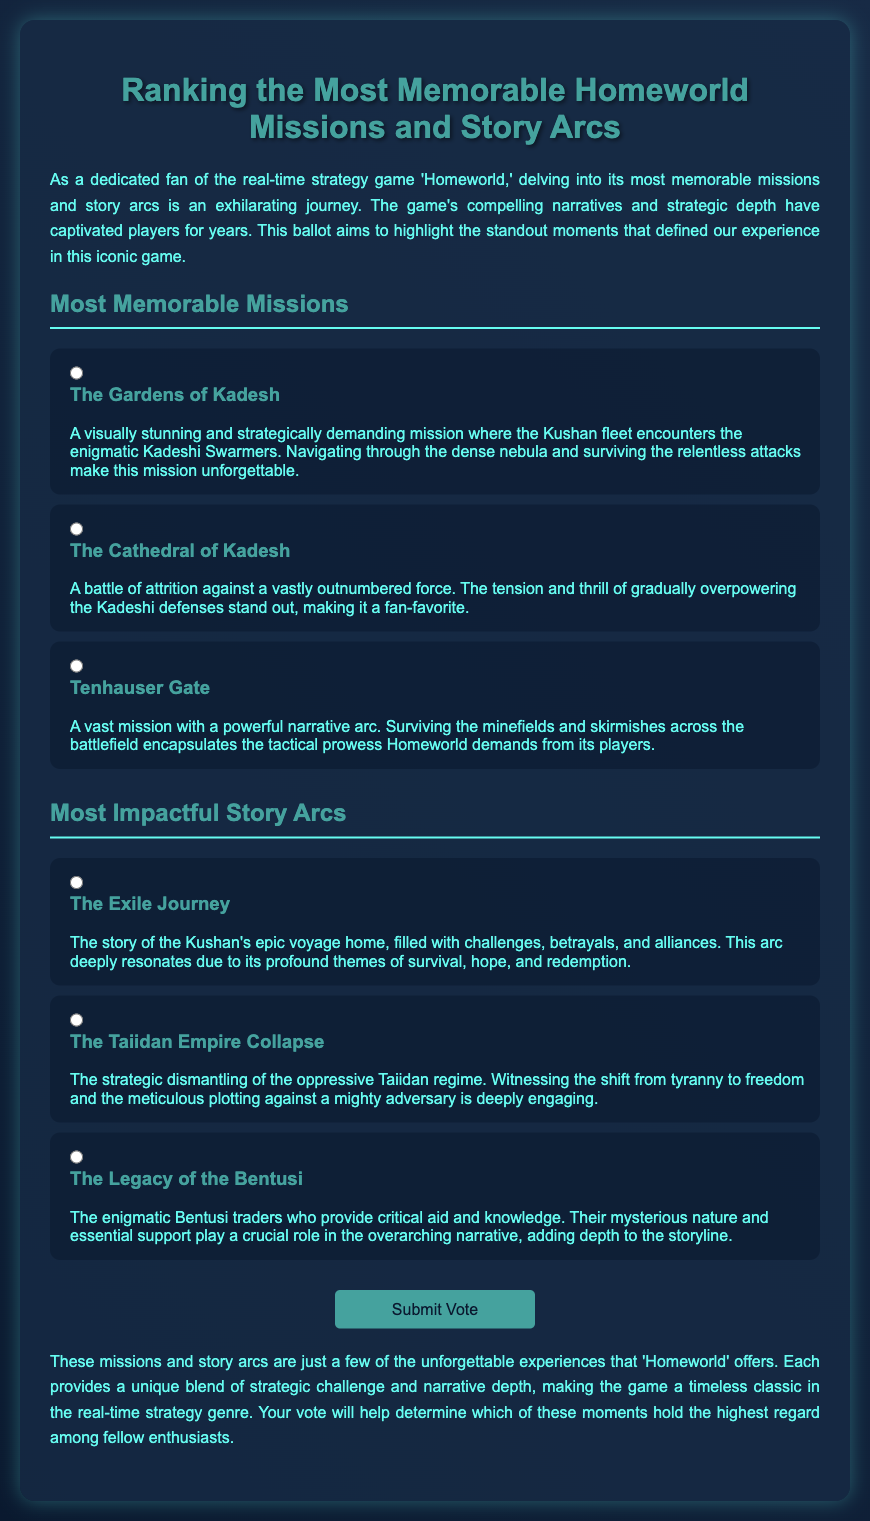what is the title of the document? The title is specified in the head section of the HTML code as "Homeworld Missions and Story Arcs Ballot."
Answer: Homeworld Missions and Story Arcs Ballot what mission is described as "A visually stunning and strategically demanding mission"? This description refers to one of the missions listed under "Most Memorable Missions," specifically highlighting its notable features.
Answer: The Gardens of Kadesh how many impactful story arcs are listed in the document? The document contains three entries under the "Most Impactful Story Arcs" category.
Answer: 3 which mission features a narrative arc involving survival through minefields? This mission is known for its tactical challenges and storyline focusing on survival amidst hazards.
Answer: Tenhauser Gate what is the name of the arc that discusses the story of the Kushan's epic voyage home? This arc is characterized by themes of survival, hope, and redemption.
Answer: The Exile Journey what color is the text for headings in the document? The text color for headings is consistently defined in the CSS styles as a specific shade of green.
Answer: #45a29e which mission involves a battle of attrition against a Kadeshi force? This mission is recognized for its tense atmosphere and tactical demands during the battle.
Answer: The Cathedral of Kadesh name one of the recurring themes in "The Taiidan Empire Collapse" story arc. This arc revolves around a significant transition from oppression to liberation.
Answer: Freedom 